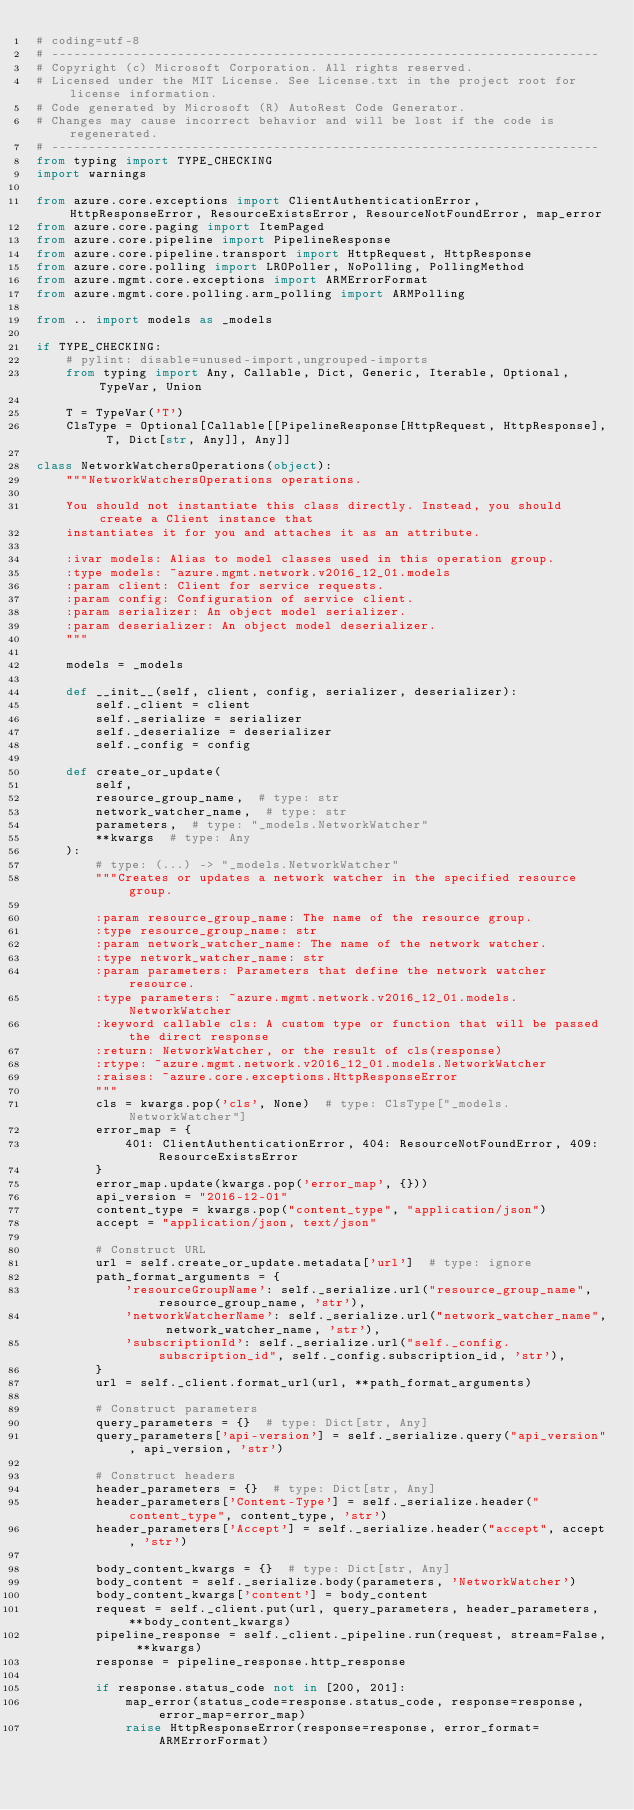Convert code to text. <code><loc_0><loc_0><loc_500><loc_500><_Python_># coding=utf-8
# --------------------------------------------------------------------------
# Copyright (c) Microsoft Corporation. All rights reserved.
# Licensed under the MIT License. See License.txt in the project root for license information.
# Code generated by Microsoft (R) AutoRest Code Generator.
# Changes may cause incorrect behavior and will be lost if the code is regenerated.
# --------------------------------------------------------------------------
from typing import TYPE_CHECKING
import warnings

from azure.core.exceptions import ClientAuthenticationError, HttpResponseError, ResourceExistsError, ResourceNotFoundError, map_error
from azure.core.paging import ItemPaged
from azure.core.pipeline import PipelineResponse
from azure.core.pipeline.transport import HttpRequest, HttpResponse
from azure.core.polling import LROPoller, NoPolling, PollingMethod
from azure.mgmt.core.exceptions import ARMErrorFormat
from azure.mgmt.core.polling.arm_polling import ARMPolling

from .. import models as _models

if TYPE_CHECKING:
    # pylint: disable=unused-import,ungrouped-imports
    from typing import Any, Callable, Dict, Generic, Iterable, Optional, TypeVar, Union

    T = TypeVar('T')
    ClsType = Optional[Callable[[PipelineResponse[HttpRequest, HttpResponse], T, Dict[str, Any]], Any]]

class NetworkWatchersOperations(object):
    """NetworkWatchersOperations operations.

    You should not instantiate this class directly. Instead, you should create a Client instance that
    instantiates it for you and attaches it as an attribute.

    :ivar models: Alias to model classes used in this operation group.
    :type models: ~azure.mgmt.network.v2016_12_01.models
    :param client: Client for service requests.
    :param config: Configuration of service client.
    :param serializer: An object model serializer.
    :param deserializer: An object model deserializer.
    """

    models = _models

    def __init__(self, client, config, serializer, deserializer):
        self._client = client
        self._serialize = serializer
        self._deserialize = deserializer
        self._config = config

    def create_or_update(
        self,
        resource_group_name,  # type: str
        network_watcher_name,  # type: str
        parameters,  # type: "_models.NetworkWatcher"
        **kwargs  # type: Any
    ):
        # type: (...) -> "_models.NetworkWatcher"
        """Creates or updates a network watcher in the specified resource group.

        :param resource_group_name: The name of the resource group.
        :type resource_group_name: str
        :param network_watcher_name: The name of the network watcher.
        :type network_watcher_name: str
        :param parameters: Parameters that define the network watcher resource.
        :type parameters: ~azure.mgmt.network.v2016_12_01.models.NetworkWatcher
        :keyword callable cls: A custom type or function that will be passed the direct response
        :return: NetworkWatcher, or the result of cls(response)
        :rtype: ~azure.mgmt.network.v2016_12_01.models.NetworkWatcher
        :raises: ~azure.core.exceptions.HttpResponseError
        """
        cls = kwargs.pop('cls', None)  # type: ClsType["_models.NetworkWatcher"]
        error_map = {
            401: ClientAuthenticationError, 404: ResourceNotFoundError, 409: ResourceExistsError
        }
        error_map.update(kwargs.pop('error_map', {}))
        api_version = "2016-12-01"
        content_type = kwargs.pop("content_type", "application/json")
        accept = "application/json, text/json"

        # Construct URL
        url = self.create_or_update.metadata['url']  # type: ignore
        path_format_arguments = {
            'resourceGroupName': self._serialize.url("resource_group_name", resource_group_name, 'str'),
            'networkWatcherName': self._serialize.url("network_watcher_name", network_watcher_name, 'str'),
            'subscriptionId': self._serialize.url("self._config.subscription_id", self._config.subscription_id, 'str'),
        }
        url = self._client.format_url(url, **path_format_arguments)

        # Construct parameters
        query_parameters = {}  # type: Dict[str, Any]
        query_parameters['api-version'] = self._serialize.query("api_version", api_version, 'str')

        # Construct headers
        header_parameters = {}  # type: Dict[str, Any]
        header_parameters['Content-Type'] = self._serialize.header("content_type", content_type, 'str')
        header_parameters['Accept'] = self._serialize.header("accept", accept, 'str')

        body_content_kwargs = {}  # type: Dict[str, Any]
        body_content = self._serialize.body(parameters, 'NetworkWatcher')
        body_content_kwargs['content'] = body_content
        request = self._client.put(url, query_parameters, header_parameters, **body_content_kwargs)
        pipeline_response = self._client._pipeline.run(request, stream=False, **kwargs)
        response = pipeline_response.http_response

        if response.status_code not in [200, 201]:
            map_error(status_code=response.status_code, response=response, error_map=error_map)
            raise HttpResponseError(response=response, error_format=ARMErrorFormat)
</code> 